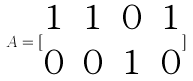<formula> <loc_0><loc_0><loc_500><loc_500>A = [ \begin{matrix} 1 & 1 & 0 & 1 \\ 0 & 0 & 1 & 0 \end{matrix} ]</formula> 